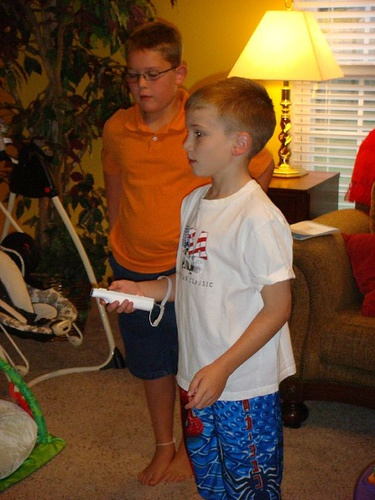Describe the objects in this image and their specific colors. I can see people in black, darkgray, gray, and navy tones, potted plant in black, maroon, and gray tones, people in black, maroon, and brown tones, couch in black, maroon, and brown tones, and chair in black, maroon, and brown tones in this image. 